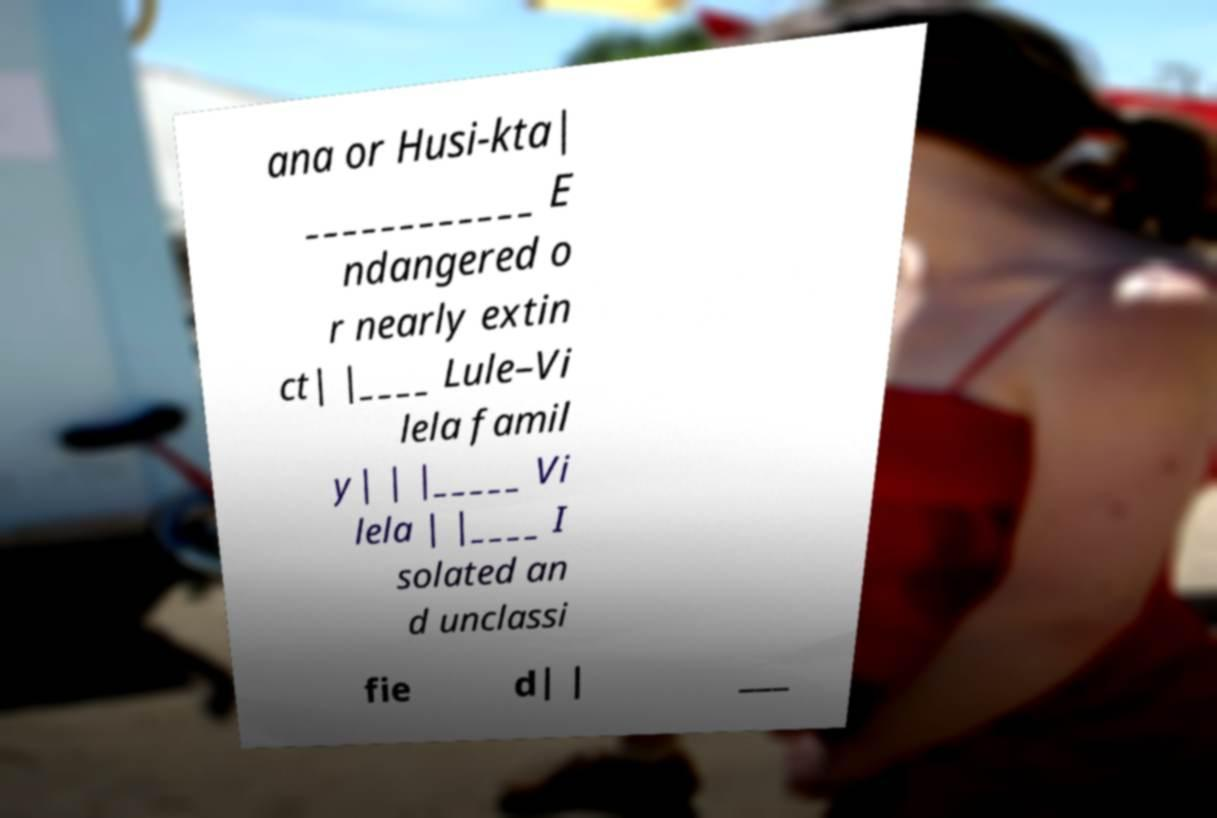Please read and relay the text visible in this image. What does it say? ana or Husi-kta| ____________ E ndangered o r nearly extin ct| |____ Lule–Vi lela famil y| | |_____ Vi lela | |____ I solated an d unclassi fie d| | ___ 